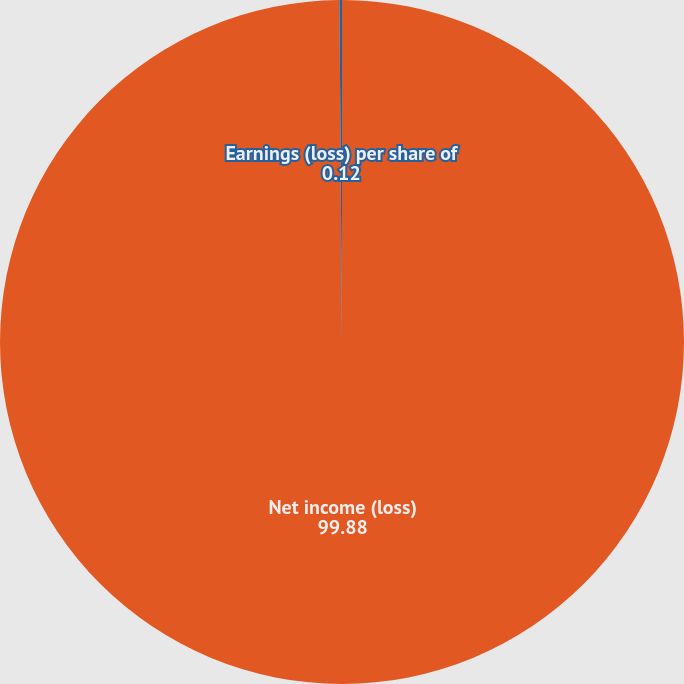Convert chart. <chart><loc_0><loc_0><loc_500><loc_500><pie_chart><fcel>Net income (loss)<fcel>Earnings (loss) per share of<nl><fcel>99.88%<fcel>0.12%<nl></chart> 